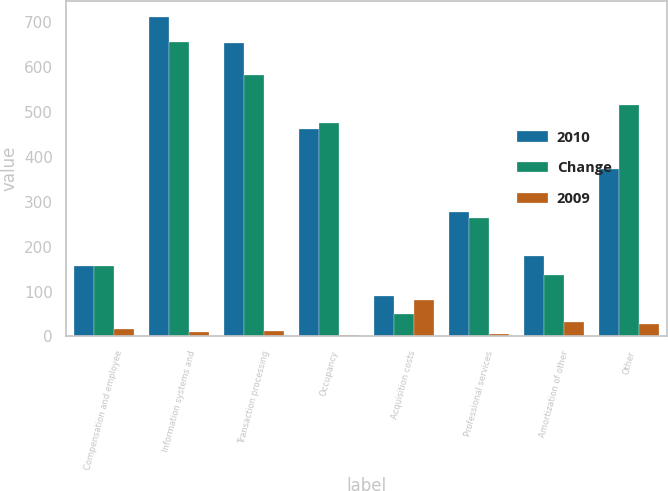Convert chart to OTSL. <chart><loc_0><loc_0><loc_500><loc_500><stacked_bar_chart><ecel><fcel>Compensation and employee<fcel>Information systems and<fcel>Transaction processing<fcel>Occupancy<fcel>Acquisition costs<fcel>Professional services<fcel>Amortization of other<fcel>Other<nl><fcel>2010<fcel>157.5<fcel>713<fcel>653<fcel>463<fcel>89<fcel>277<fcel>179<fcel>374<nl><fcel>Change<fcel>157.5<fcel>656<fcel>583<fcel>475<fcel>49<fcel>264<fcel>136<fcel>516<nl><fcel>2009<fcel>16<fcel>9<fcel>12<fcel>3<fcel>82<fcel>5<fcel>32<fcel>28<nl></chart> 